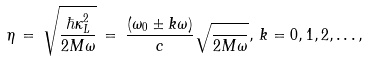<formula> <loc_0><loc_0><loc_500><loc_500>\eta \, = \, \sqrt { \frac { \hbar { \kappa } _ { L } ^ { 2 } } { 2 M \omega } } \, = \, \frac { ( \omega _ { 0 } \pm k \omega ) } { c } \sqrt { \frac { } { 2 M \omega } } , \, k = 0 , 1 , 2 , \dots ,</formula> 